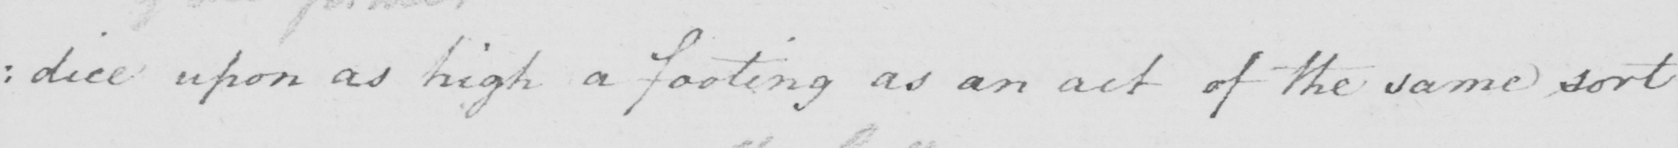Transcribe the text shown in this historical manuscript line. : dice upon as high a footing as an act of the same sort 